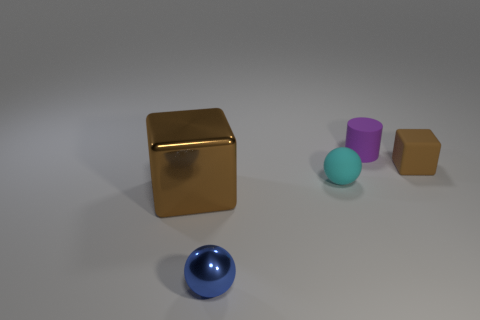Is there anything else that has the same size as the shiny cube?
Offer a very short reply. No. Do the blue object in front of the brown metal object and the big shiny block have the same size?
Your answer should be very brief. No. What number of other things are there of the same size as the blue thing?
Offer a terse response. 3. Are any small gray shiny balls visible?
Ensure brevity in your answer.  No. What size is the thing that is right of the rubber object that is behind the tiny brown thing?
Provide a succinct answer. Small. There is a cube to the left of the small matte cylinder; is it the same color as the small object that is behind the tiny brown rubber block?
Offer a terse response. No. What color is the tiny thing that is in front of the small matte block and on the right side of the blue metallic ball?
Give a very brief answer. Cyan. What number of other things are there of the same shape as the brown matte thing?
Your response must be concise. 1. What color is the other matte sphere that is the same size as the blue ball?
Give a very brief answer. Cyan. There is a tiny object to the right of the tiny cylinder; what color is it?
Your answer should be very brief. Brown. 